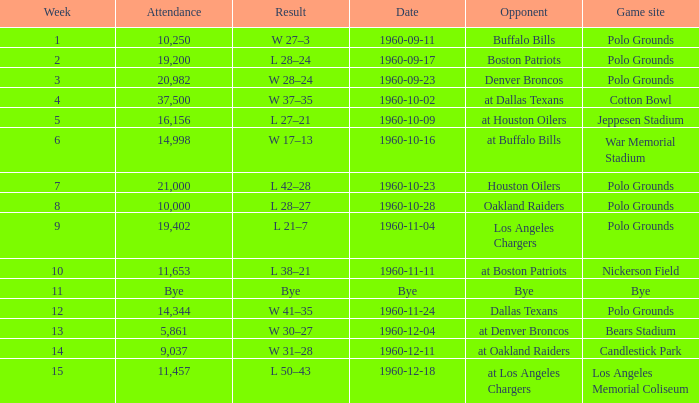What day had 37,500 attending? 1960-10-02. Can you parse all the data within this table? {'header': ['Week', 'Attendance', 'Result', 'Date', 'Opponent', 'Game site'], 'rows': [['1', '10,250', 'W 27–3', '1960-09-11', 'Buffalo Bills', 'Polo Grounds'], ['2', '19,200', 'L 28–24', '1960-09-17', 'Boston Patriots', 'Polo Grounds'], ['3', '20,982', 'W 28–24', '1960-09-23', 'Denver Broncos', 'Polo Grounds'], ['4', '37,500', 'W 37–35', '1960-10-02', 'at Dallas Texans', 'Cotton Bowl'], ['5', '16,156', 'L 27–21', '1960-10-09', 'at Houston Oilers', 'Jeppesen Stadium'], ['6', '14,998', 'W 17–13', '1960-10-16', 'at Buffalo Bills', 'War Memorial Stadium'], ['7', '21,000', 'L 42–28', '1960-10-23', 'Houston Oilers', 'Polo Grounds'], ['8', '10,000', 'L 28–27', '1960-10-28', 'Oakland Raiders', 'Polo Grounds'], ['9', '19,402', 'L 21–7', '1960-11-04', 'Los Angeles Chargers', 'Polo Grounds'], ['10', '11,653', 'L 38–21', '1960-11-11', 'at Boston Patriots', 'Nickerson Field'], ['11', 'Bye', 'Bye', 'Bye', 'Bye', 'Bye'], ['12', '14,344', 'W 41–35', '1960-11-24', 'Dallas Texans', 'Polo Grounds'], ['13', '5,861', 'W 30–27', '1960-12-04', 'at Denver Broncos', 'Bears Stadium'], ['14', '9,037', 'W 31–28', '1960-12-11', 'at Oakland Raiders', 'Candlestick Park'], ['15', '11,457', 'L 50–43', '1960-12-18', 'at Los Angeles Chargers', 'Los Angeles Memorial Coliseum']]} 